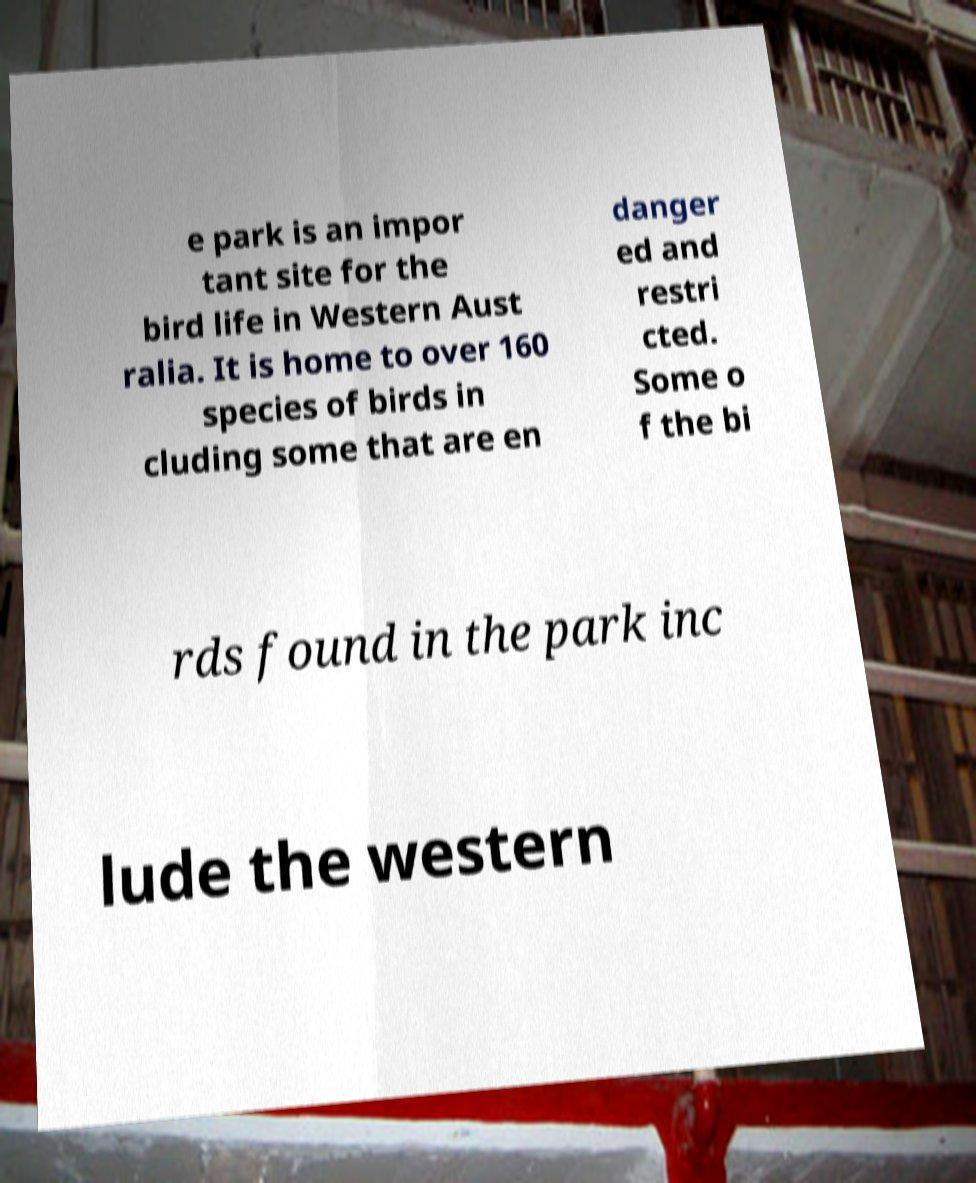Please read and relay the text visible in this image. What does it say? e park is an impor tant site for the bird life in Western Aust ralia. It is home to over 160 species of birds in cluding some that are en danger ed and restri cted. Some o f the bi rds found in the park inc lude the western 